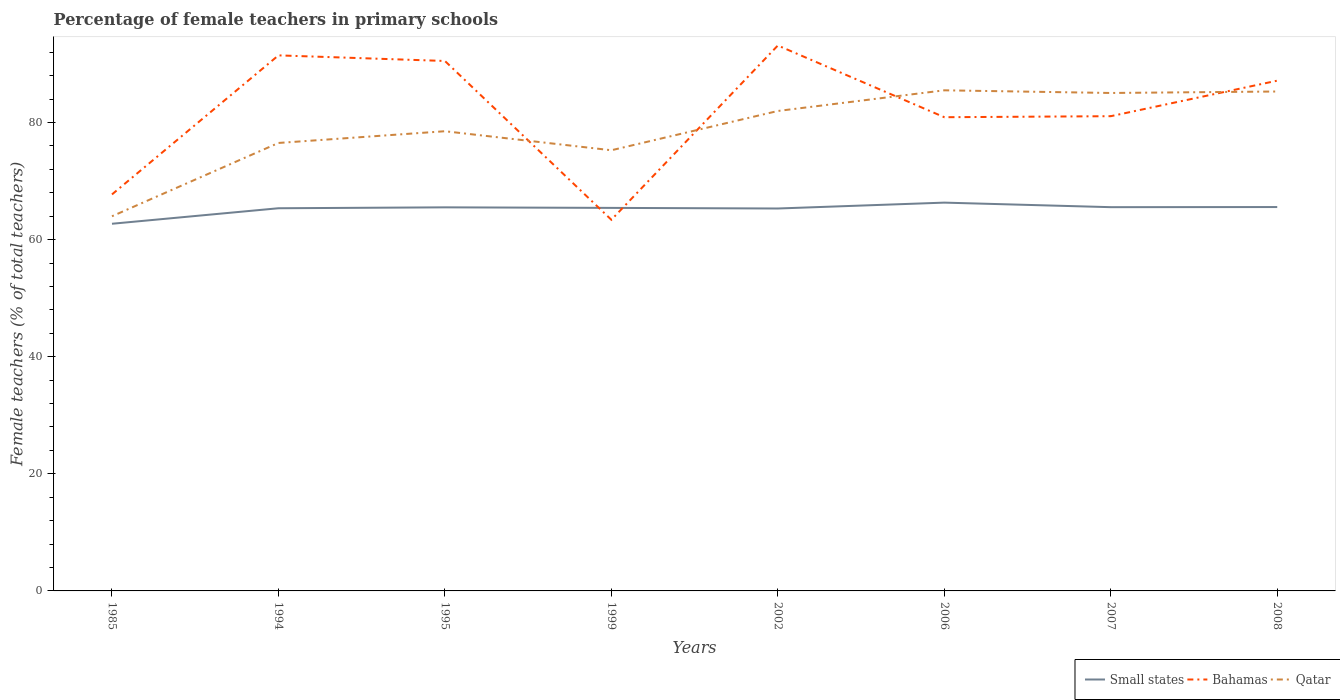Across all years, what is the maximum percentage of female teachers in Qatar?
Give a very brief answer. 63.98. What is the total percentage of female teachers in Bahamas in the graph?
Provide a short and direct response. -6.24. What is the difference between the highest and the second highest percentage of female teachers in Qatar?
Keep it short and to the point. 21.51. What is the difference between the highest and the lowest percentage of female teachers in Small states?
Your response must be concise. 7. How many years are there in the graph?
Offer a very short reply. 8. Does the graph contain any zero values?
Provide a short and direct response. No. Does the graph contain grids?
Provide a succinct answer. No. How many legend labels are there?
Provide a succinct answer. 3. How are the legend labels stacked?
Provide a short and direct response. Horizontal. What is the title of the graph?
Make the answer very short. Percentage of female teachers in primary schools. What is the label or title of the X-axis?
Your answer should be very brief. Years. What is the label or title of the Y-axis?
Provide a succinct answer. Female teachers (% of total teachers). What is the Female teachers (% of total teachers) in Small states in 1985?
Your response must be concise. 62.7. What is the Female teachers (% of total teachers) of Bahamas in 1985?
Offer a very short reply. 67.71. What is the Female teachers (% of total teachers) in Qatar in 1985?
Make the answer very short. 63.98. What is the Female teachers (% of total teachers) of Small states in 1994?
Make the answer very short. 65.35. What is the Female teachers (% of total teachers) of Bahamas in 1994?
Keep it short and to the point. 91.46. What is the Female teachers (% of total teachers) of Qatar in 1994?
Give a very brief answer. 76.5. What is the Female teachers (% of total teachers) of Small states in 1995?
Give a very brief answer. 65.51. What is the Female teachers (% of total teachers) of Bahamas in 1995?
Make the answer very short. 90.51. What is the Female teachers (% of total teachers) of Qatar in 1995?
Your response must be concise. 78.51. What is the Female teachers (% of total teachers) of Small states in 1999?
Make the answer very short. 65.41. What is the Female teachers (% of total teachers) in Bahamas in 1999?
Your answer should be very brief. 63.38. What is the Female teachers (% of total teachers) of Qatar in 1999?
Keep it short and to the point. 75.26. What is the Female teachers (% of total teachers) in Small states in 2002?
Provide a short and direct response. 65.31. What is the Female teachers (% of total teachers) in Bahamas in 2002?
Ensure brevity in your answer.  93.15. What is the Female teachers (% of total teachers) of Qatar in 2002?
Offer a terse response. 81.97. What is the Female teachers (% of total teachers) of Small states in 2006?
Your response must be concise. 66.31. What is the Female teachers (% of total teachers) in Bahamas in 2006?
Provide a short and direct response. 80.9. What is the Female teachers (% of total teachers) of Qatar in 2006?
Provide a succinct answer. 85.49. What is the Female teachers (% of total teachers) of Small states in 2007?
Your response must be concise. 65.54. What is the Female teachers (% of total teachers) in Bahamas in 2007?
Keep it short and to the point. 81.07. What is the Female teachers (% of total teachers) in Qatar in 2007?
Your response must be concise. 85.04. What is the Female teachers (% of total teachers) of Small states in 2008?
Make the answer very short. 65.56. What is the Female teachers (% of total teachers) in Bahamas in 2008?
Ensure brevity in your answer.  87.14. What is the Female teachers (% of total teachers) of Qatar in 2008?
Make the answer very short. 85.29. Across all years, what is the maximum Female teachers (% of total teachers) of Small states?
Your response must be concise. 66.31. Across all years, what is the maximum Female teachers (% of total teachers) of Bahamas?
Keep it short and to the point. 93.15. Across all years, what is the maximum Female teachers (% of total teachers) in Qatar?
Provide a succinct answer. 85.49. Across all years, what is the minimum Female teachers (% of total teachers) of Small states?
Your response must be concise. 62.7. Across all years, what is the minimum Female teachers (% of total teachers) of Bahamas?
Provide a short and direct response. 63.38. Across all years, what is the minimum Female teachers (% of total teachers) in Qatar?
Ensure brevity in your answer.  63.98. What is the total Female teachers (% of total teachers) of Small states in the graph?
Offer a terse response. 521.7. What is the total Female teachers (% of total teachers) of Bahamas in the graph?
Provide a succinct answer. 655.33. What is the total Female teachers (% of total teachers) of Qatar in the graph?
Provide a succinct answer. 632.04. What is the difference between the Female teachers (% of total teachers) of Small states in 1985 and that in 1994?
Give a very brief answer. -2.65. What is the difference between the Female teachers (% of total teachers) of Bahamas in 1985 and that in 1994?
Your answer should be compact. -23.75. What is the difference between the Female teachers (% of total teachers) in Qatar in 1985 and that in 1994?
Your response must be concise. -12.52. What is the difference between the Female teachers (% of total teachers) in Small states in 1985 and that in 1995?
Your answer should be very brief. -2.8. What is the difference between the Female teachers (% of total teachers) in Bahamas in 1985 and that in 1995?
Give a very brief answer. -22.79. What is the difference between the Female teachers (% of total teachers) of Qatar in 1985 and that in 1995?
Offer a very short reply. -14.52. What is the difference between the Female teachers (% of total teachers) in Small states in 1985 and that in 1999?
Your response must be concise. -2.71. What is the difference between the Female teachers (% of total teachers) in Bahamas in 1985 and that in 1999?
Ensure brevity in your answer.  4.33. What is the difference between the Female teachers (% of total teachers) in Qatar in 1985 and that in 1999?
Give a very brief answer. -11.27. What is the difference between the Female teachers (% of total teachers) of Small states in 1985 and that in 2002?
Your answer should be very brief. -2.61. What is the difference between the Female teachers (% of total teachers) in Bahamas in 1985 and that in 2002?
Your answer should be very brief. -25.44. What is the difference between the Female teachers (% of total teachers) of Qatar in 1985 and that in 2002?
Ensure brevity in your answer.  -17.98. What is the difference between the Female teachers (% of total teachers) of Small states in 1985 and that in 2006?
Offer a terse response. -3.61. What is the difference between the Female teachers (% of total teachers) of Bahamas in 1985 and that in 2006?
Your response must be concise. -13.19. What is the difference between the Female teachers (% of total teachers) in Qatar in 1985 and that in 2006?
Provide a short and direct response. -21.51. What is the difference between the Female teachers (% of total teachers) in Small states in 1985 and that in 2007?
Provide a short and direct response. -2.83. What is the difference between the Female teachers (% of total teachers) of Bahamas in 1985 and that in 2007?
Your response must be concise. -13.36. What is the difference between the Female teachers (% of total teachers) in Qatar in 1985 and that in 2007?
Your answer should be very brief. -21.05. What is the difference between the Female teachers (% of total teachers) in Small states in 1985 and that in 2008?
Offer a very short reply. -2.85. What is the difference between the Female teachers (% of total teachers) in Bahamas in 1985 and that in 2008?
Keep it short and to the point. -19.43. What is the difference between the Female teachers (% of total teachers) in Qatar in 1985 and that in 2008?
Make the answer very short. -21.31. What is the difference between the Female teachers (% of total teachers) of Small states in 1994 and that in 1995?
Your answer should be compact. -0.15. What is the difference between the Female teachers (% of total teachers) in Bahamas in 1994 and that in 1995?
Your answer should be very brief. 0.96. What is the difference between the Female teachers (% of total teachers) in Qatar in 1994 and that in 1995?
Keep it short and to the point. -2. What is the difference between the Female teachers (% of total teachers) in Small states in 1994 and that in 1999?
Make the answer very short. -0.06. What is the difference between the Female teachers (% of total teachers) of Bahamas in 1994 and that in 1999?
Offer a terse response. 28.08. What is the difference between the Female teachers (% of total teachers) in Qatar in 1994 and that in 1999?
Offer a very short reply. 1.24. What is the difference between the Female teachers (% of total teachers) in Small states in 1994 and that in 2002?
Your response must be concise. 0.04. What is the difference between the Female teachers (% of total teachers) in Bahamas in 1994 and that in 2002?
Your answer should be very brief. -1.69. What is the difference between the Female teachers (% of total teachers) in Qatar in 1994 and that in 2002?
Your answer should be very brief. -5.46. What is the difference between the Female teachers (% of total teachers) of Small states in 1994 and that in 2006?
Offer a very short reply. -0.96. What is the difference between the Female teachers (% of total teachers) of Bahamas in 1994 and that in 2006?
Provide a short and direct response. 10.56. What is the difference between the Female teachers (% of total teachers) in Qatar in 1994 and that in 2006?
Offer a terse response. -8.99. What is the difference between the Female teachers (% of total teachers) in Small states in 1994 and that in 2007?
Ensure brevity in your answer.  -0.18. What is the difference between the Female teachers (% of total teachers) of Bahamas in 1994 and that in 2007?
Provide a short and direct response. 10.39. What is the difference between the Female teachers (% of total teachers) of Qatar in 1994 and that in 2007?
Provide a succinct answer. -8.54. What is the difference between the Female teachers (% of total teachers) in Small states in 1994 and that in 2008?
Make the answer very short. -0.21. What is the difference between the Female teachers (% of total teachers) of Bahamas in 1994 and that in 2008?
Your answer should be very brief. 4.32. What is the difference between the Female teachers (% of total teachers) in Qatar in 1994 and that in 2008?
Your answer should be very brief. -8.79. What is the difference between the Female teachers (% of total teachers) in Small states in 1995 and that in 1999?
Offer a very short reply. 0.09. What is the difference between the Female teachers (% of total teachers) of Bahamas in 1995 and that in 1999?
Your answer should be very brief. 27.12. What is the difference between the Female teachers (% of total teachers) in Qatar in 1995 and that in 1999?
Your response must be concise. 3.25. What is the difference between the Female teachers (% of total teachers) of Small states in 1995 and that in 2002?
Offer a very short reply. 0.2. What is the difference between the Female teachers (% of total teachers) in Bahamas in 1995 and that in 2002?
Provide a succinct answer. -2.64. What is the difference between the Female teachers (% of total teachers) of Qatar in 1995 and that in 2002?
Offer a very short reply. -3.46. What is the difference between the Female teachers (% of total teachers) of Small states in 1995 and that in 2006?
Offer a terse response. -0.81. What is the difference between the Female teachers (% of total teachers) of Bahamas in 1995 and that in 2006?
Provide a succinct answer. 9.61. What is the difference between the Female teachers (% of total teachers) of Qatar in 1995 and that in 2006?
Your answer should be very brief. -6.99. What is the difference between the Female teachers (% of total teachers) in Small states in 1995 and that in 2007?
Your response must be concise. -0.03. What is the difference between the Female teachers (% of total teachers) in Bahamas in 1995 and that in 2007?
Offer a very short reply. 9.43. What is the difference between the Female teachers (% of total teachers) in Qatar in 1995 and that in 2007?
Your answer should be very brief. -6.53. What is the difference between the Female teachers (% of total teachers) of Small states in 1995 and that in 2008?
Offer a very short reply. -0.05. What is the difference between the Female teachers (% of total teachers) in Bahamas in 1995 and that in 2008?
Offer a terse response. 3.36. What is the difference between the Female teachers (% of total teachers) of Qatar in 1995 and that in 2008?
Offer a terse response. -6.78. What is the difference between the Female teachers (% of total teachers) in Small states in 1999 and that in 2002?
Offer a very short reply. 0.1. What is the difference between the Female teachers (% of total teachers) in Bahamas in 1999 and that in 2002?
Your response must be concise. -29.77. What is the difference between the Female teachers (% of total teachers) in Qatar in 1999 and that in 2002?
Your response must be concise. -6.71. What is the difference between the Female teachers (% of total teachers) in Small states in 1999 and that in 2006?
Your answer should be very brief. -0.9. What is the difference between the Female teachers (% of total teachers) of Bahamas in 1999 and that in 2006?
Ensure brevity in your answer.  -17.52. What is the difference between the Female teachers (% of total teachers) in Qatar in 1999 and that in 2006?
Your response must be concise. -10.24. What is the difference between the Female teachers (% of total teachers) of Small states in 1999 and that in 2007?
Provide a short and direct response. -0.12. What is the difference between the Female teachers (% of total teachers) of Bahamas in 1999 and that in 2007?
Make the answer very short. -17.69. What is the difference between the Female teachers (% of total teachers) of Qatar in 1999 and that in 2007?
Offer a terse response. -9.78. What is the difference between the Female teachers (% of total teachers) in Small states in 1999 and that in 2008?
Make the answer very short. -0.14. What is the difference between the Female teachers (% of total teachers) in Bahamas in 1999 and that in 2008?
Provide a short and direct response. -23.76. What is the difference between the Female teachers (% of total teachers) in Qatar in 1999 and that in 2008?
Offer a terse response. -10.03. What is the difference between the Female teachers (% of total teachers) in Small states in 2002 and that in 2006?
Keep it short and to the point. -1. What is the difference between the Female teachers (% of total teachers) in Bahamas in 2002 and that in 2006?
Ensure brevity in your answer.  12.25. What is the difference between the Female teachers (% of total teachers) of Qatar in 2002 and that in 2006?
Your answer should be compact. -3.53. What is the difference between the Female teachers (% of total teachers) of Small states in 2002 and that in 2007?
Ensure brevity in your answer.  -0.23. What is the difference between the Female teachers (% of total teachers) in Bahamas in 2002 and that in 2007?
Ensure brevity in your answer.  12.07. What is the difference between the Female teachers (% of total teachers) in Qatar in 2002 and that in 2007?
Ensure brevity in your answer.  -3.07. What is the difference between the Female teachers (% of total teachers) of Small states in 2002 and that in 2008?
Ensure brevity in your answer.  -0.25. What is the difference between the Female teachers (% of total teachers) of Bahamas in 2002 and that in 2008?
Offer a terse response. 6.01. What is the difference between the Female teachers (% of total teachers) in Qatar in 2002 and that in 2008?
Give a very brief answer. -3.33. What is the difference between the Female teachers (% of total teachers) in Small states in 2006 and that in 2007?
Offer a very short reply. 0.78. What is the difference between the Female teachers (% of total teachers) of Bahamas in 2006 and that in 2007?
Your answer should be very brief. -0.17. What is the difference between the Female teachers (% of total teachers) in Qatar in 2006 and that in 2007?
Offer a terse response. 0.46. What is the difference between the Female teachers (% of total teachers) of Small states in 2006 and that in 2008?
Keep it short and to the point. 0.75. What is the difference between the Female teachers (% of total teachers) in Bahamas in 2006 and that in 2008?
Ensure brevity in your answer.  -6.24. What is the difference between the Female teachers (% of total teachers) in Qatar in 2006 and that in 2008?
Make the answer very short. 0.2. What is the difference between the Female teachers (% of total teachers) of Small states in 2007 and that in 2008?
Offer a very short reply. -0.02. What is the difference between the Female teachers (% of total teachers) of Bahamas in 2007 and that in 2008?
Keep it short and to the point. -6.07. What is the difference between the Female teachers (% of total teachers) in Qatar in 2007 and that in 2008?
Make the answer very short. -0.25. What is the difference between the Female teachers (% of total teachers) of Small states in 1985 and the Female teachers (% of total teachers) of Bahamas in 1994?
Give a very brief answer. -28.76. What is the difference between the Female teachers (% of total teachers) in Small states in 1985 and the Female teachers (% of total teachers) in Qatar in 1994?
Your answer should be compact. -13.8. What is the difference between the Female teachers (% of total teachers) of Bahamas in 1985 and the Female teachers (% of total teachers) of Qatar in 1994?
Provide a short and direct response. -8.79. What is the difference between the Female teachers (% of total teachers) of Small states in 1985 and the Female teachers (% of total teachers) of Bahamas in 1995?
Offer a terse response. -27.8. What is the difference between the Female teachers (% of total teachers) of Small states in 1985 and the Female teachers (% of total teachers) of Qatar in 1995?
Keep it short and to the point. -15.8. What is the difference between the Female teachers (% of total teachers) of Bahamas in 1985 and the Female teachers (% of total teachers) of Qatar in 1995?
Offer a terse response. -10.79. What is the difference between the Female teachers (% of total teachers) in Small states in 1985 and the Female teachers (% of total teachers) in Bahamas in 1999?
Your answer should be very brief. -0.68. What is the difference between the Female teachers (% of total teachers) in Small states in 1985 and the Female teachers (% of total teachers) in Qatar in 1999?
Keep it short and to the point. -12.55. What is the difference between the Female teachers (% of total teachers) of Bahamas in 1985 and the Female teachers (% of total teachers) of Qatar in 1999?
Offer a terse response. -7.55. What is the difference between the Female teachers (% of total teachers) of Small states in 1985 and the Female teachers (% of total teachers) of Bahamas in 2002?
Give a very brief answer. -30.45. What is the difference between the Female teachers (% of total teachers) of Small states in 1985 and the Female teachers (% of total teachers) of Qatar in 2002?
Provide a succinct answer. -19.26. What is the difference between the Female teachers (% of total teachers) of Bahamas in 1985 and the Female teachers (% of total teachers) of Qatar in 2002?
Offer a terse response. -14.25. What is the difference between the Female teachers (% of total teachers) of Small states in 1985 and the Female teachers (% of total teachers) of Bahamas in 2006?
Keep it short and to the point. -18.2. What is the difference between the Female teachers (% of total teachers) of Small states in 1985 and the Female teachers (% of total teachers) of Qatar in 2006?
Your answer should be very brief. -22.79. What is the difference between the Female teachers (% of total teachers) in Bahamas in 1985 and the Female teachers (% of total teachers) in Qatar in 2006?
Offer a terse response. -17.78. What is the difference between the Female teachers (% of total teachers) in Small states in 1985 and the Female teachers (% of total teachers) in Bahamas in 2007?
Your answer should be very brief. -18.37. What is the difference between the Female teachers (% of total teachers) of Small states in 1985 and the Female teachers (% of total teachers) of Qatar in 2007?
Keep it short and to the point. -22.33. What is the difference between the Female teachers (% of total teachers) of Bahamas in 1985 and the Female teachers (% of total teachers) of Qatar in 2007?
Give a very brief answer. -17.33. What is the difference between the Female teachers (% of total teachers) of Small states in 1985 and the Female teachers (% of total teachers) of Bahamas in 2008?
Keep it short and to the point. -24.44. What is the difference between the Female teachers (% of total teachers) of Small states in 1985 and the Female teachers (% of total teachers) of Qatar in 2008?
Offer a terse response. -22.59. What is the difference between the Female teachers (% of total teachers) in Bahamas in 1985 and the Female teachers (% of total teachers) in Qatar in 2008?
Make the answer very short. -17.58. What is the difference between the Female teachers (% of total teachers) of Small states in 1994 and the Female teachers (% of total teachers) of Bahamas in 1995?
Ensure brevity in your answer.  -25.15. What is the difference between the Female teachers (% of total teachers) of Small states in 1994 and the Female teachers (% of total teachers) of Qatar in 1995?
Ensure brevity in your answer.  -13.15. What is the difference between the Female teachers (% of total teachers) of Bahamas in 1994 and the Female teachers (% of total teachers) of Qatar in 1995?
Provide a short and direct response. 12.95. What is the difference between the Female teachers (% of total teachers) in Small states in 1994 and the Female teachers (% of total teachers) in Bahamas in 1999?
Make the answer very short. 1.97. What is the difference between the Female teachers (% of total teachers) in Small states in 1994 and the Female teachers (% of total teachers) in Qatar in 1999?
Provide a short and direct response. -9.91. What is the difference between the Female teachers (% of total teachers) in Bahamas in 1994 and the Female teachers (% of total teachers) in Qatar in 1999?
Keep it short and to the point. 16.2. What is the difference between the Female teachers (% of total teachers) of Small states in 1994 and the Female teachers (% of total teachers) of Bahamas in 2002?
Provide a short and direct response. -27.8. What is the difference between the Female teachers (% of total teachers) of Small states in 1994 and the Female teachers (% of total teachers) of Qatar in 2002?
Provide a short and direct response. -16.61. What is the difference between the Female teachers (% of total teachers) in Bahamas in 1994 and the Female teachers (% of total teachers) in Qatar in 2002?
Offer a terse response. 9.5. What is the difference between the Female teachers (% of total teachers) of Small states in 1994 and the Female teachers (% of total teachers) of Bahamas in 2006?
Your answer should be very brief. -15.55. What is the difference between the Female teachers (% of total teachers) in Small states in 1994 and the Female teachers (% of total teachers) in Qatar in 2006?
Provide a succinct answer. -20.14. What is the difference between the Female teachers (% of total teachers) of Bahamas in 1994 and the Female teachers (% of total teachers) of Qatar in 2006?
Provide a short and direct response. 5.97. What is the difference between the Female teachers (% of total teachers) in Small states in 1994 and the Female teachers (% of total teachers) in Bahamas in 2007?
Provide a short and direct response. -15.72. What is the difference between the Female teachers (% of total teachers) of Small states in 1994 and the Female teachers (% of total teachers) of Qatar in 2007?
Ensure brevity in your answer.  -19.69. What is the difference between the Female teachers (% of total teachers) in Bahamas in 1994 and the Female teachers (% of total teachers) in Qatar in 2007?
Your answer should be very brief. 6.42. What is the difference between the Female teachers (% of total teachers) in Small states in 1994 and the Female teachers (% of total teachers) in Bahamas in 2008?
Ensure brevity in your answer.  -21.79. What is the difference between the Female teachers (% of total teachers) in Small states in 1994 and the Female teachers (% of total teachers) in Qatar in 2008?
Offer a very short reply. -19.94. What is the difference between the Female teachers (% of total teachers) in Bahamas in 1994 and the Female teachers (% of total teachers) in Qatar in 2008?
Offer a very short reply. 6.17. What is the difference between the Female teachers (% of total teachers) in Small states in 1995 and the Female teachers (% of total teachers) in Bahamas in 1999?
Provide a short and direct response. 2.12. What is the difference between the Female teachers (% of total teachers) in Small states in 1995 and the Female teachers (% of total teachers) in Qatar in 1999?
Your answer should be compact. -9.75. What is the difference between the Female teachers (% of total teachers) of Bahamas in 1995 and the Female teachers (% of total teachers) of Qatar in 1999?
Ensure brevity in your answer.  15.25. What is the difference between the Female teachers (% of total teachers) in Small states in 1995 and the Female teachers (% of total teachers) in Bahamas in 2002?
Ensure brevity in your answer.  -27.64. What is the difference between the Female teachers (% of total teachers) in Small states in 1995 and the Female teachers (% of total teachers) in Qatar in 2002?
Provide a succinct answer. -16.46. What is the difference between the Female teachers (% of total teachers) of Bahamas in 1995 and the Female teachers (% of total teachers) of Qatar in 2002?
Make the answer very short. 8.54. What is the difference between the Female teachers (% of total teachers) in Small states in 1995 and the Female teachers (% of total teachers) in Bahamas in 2006?
Your answer should be compact. -15.39. What is the difference between the Female teachers (% of total teachers) of Small states in 1995 and the Female teachers (% of total teachers) of Qatar in 2006?
Offer a very short reply. -19.99. What is the difference between the Female teachers (% of total teachers) in Bahamas in 1995 and the Female teachers (% of total teachers) in Qatar in 2006?
Your response must be concise. 5.01. What is the difference between the Female teachers (% of total teachers) in Small states in 1995 and the Female teachers (% of total teachers) in Bahamas in 2007?
Give a very brief answer. -15.57. What is the difference between the Female teachers (% of total teachers) in Small states in 1995 and the Female teachers (% of total teachers) in Qatar in 2007?
Your response must be concise. -19.53. What is the difference between the Female teachers (% of total teachers) in Bahamas in 1995 and the Female teachers (% of total teachers) in Qatar in 2007?
Offer a very short reply. 5.47. What is the difference between the Female teachers (% of total teachers) of Small states in 1995 and the Female teachers (% of total teachers) of Bahamas in 2008?
Your response must be concise. -21.63. What is the difference between the Female teachers (% of total teachers) in Small states in 1995 and the Female teachers (% of total teachers) in Qatar in 2008?
Your response must be concise. -19.78. What is the difference between the Female teachers (% of total teachers) in Bahamas in 1995 and the Female teachers (% of total teachers) in Qatar in 2008?
Make the answer very short. 5.21. What is the difference between the Female teachers (% of total teachers) in Small states in 1999 and the Female teachers (% of total teachers) in Bahamas in 2002?
Give a very brief answer. -27.73. What is the difference between the Female teachers (% of total teachers) of Small states in 1999 and the Female teachers (% of total teachers) of Qatar in 2002?
Make the answer very short. -16.55. What is the difference between the Female teachers (% of total teachers) in Bahamas in 1999 and the Female teachers (% of total teachers) in Qatar in 2002?
Provide a succinct answer. -18.58. What is the difference between the Female teachers (% of total teachers) in Small states in 1999 and the Female teachers (% of total teachers) in Bahamas in 2006?
Offer a terse response. -15.48. What is the difference between the Female teachers (% of total teachers) in Small states in 1999 and the Female teachers (% of total teachers) in Qatar in 2006?
Make the answer very short. -20.08. What is the difference between the Female teachers (% of total teachers) in Bahamas in 1999 and the Female teachers (% of total teachers) in Qatar in 2006?
Your answer should be compact. -22.11. What is the difference between the Female teachers (% of total teachers) in Small states in 1999 and the Female teachers (% of total teachers) in Bahamas in 2007?
Ensure brevity in your answer.  -15.66. What is the difference between the Female teachers (% of total teachers) in Small states in 1999 and the Female teachers (% of total teachers) in Qatar in 2007?
Offer a very short reply. -19.62. What is the difference between the Female teachers (% of total teachers) in Bahamas in 1999 and the Female teachers (% of total teachers) in Qatar in 2007?
Ensure brevity in your answer.  -21.66. What is the difference between the Female teachers (% of total teachers) of Small states in 1999 and the Female teachers (% of total teachers) of Bahamas in 2008?
Your answer should be very brief. -21.73. What is the difference between the Female teachers (% of total teachers) in Small states in 1999 and the Female teachers (% of total teachers) in Qatar in 2008?
Offer a very short reply. -19.88. What is the difference between the Female teachers (% of total teachers) in Bahamas in 1999 and the Female teachers (% of total teachers) in Qatar in 2008?
Keep it short and to the point. -21.91. What is the difference between the Female teachers (% of total teachers) of Small states in 2002 and the Female teachers (% of total teachers) of Bahamas in 2006?
Keep it short and to the point. -15.59. What is the difference between the Female teachers (% of total teachers) in Small states in 2002 and the Female teachers (% of total teachers) in Qatar in 2006?
Your response must be concise. -20.18. What is the difference between the Female teachers (% of total teachers) of Bahamas in 2002 and the Female teachers (% of total teachers) of Qatar in 2006?
Offer a terse response. 7.65. What is the difference between the Female teachers (% of total teachers) in Small states in 2002 and the Female teachers (% of total teachers) in Bahamas in 2007?
Your answer should be very brief. -15.76. What is the difference between the Female teachers (% of total teachers) of Small states in 2002 and the Female teachers (% of total teachers) of Qatar in 2007?
Your answer should be very brief. -19.73. What is the difference between the Female teachers (% of total teachers) of Bahamas in 2002 and the Female teachers (% of total teachers) of Qatar in 2007?
Make the answer very short. 8.11. What is the difference between the Female teachers (% of total teachers) in Small states in 2002 and the Female teachers (% of total teachers) in Bahamas in 2008?
Provide a succinct answer. -21.83. What is the difference between the Female teachers (% of total teachers) in Small states in 2002 and the Female teachers (% of total teachers) in Qatar in 2008?
Offer a very short reply. -19.98. What is the difference between the Female teachers (% of total teachers) in Bahamas in 2002 and the Female teachers (% of total teachers) in Qatar in 2008?
Your answer should be compact. 7.86. What is the difference between the Female teachers (% of total teachers) of Small states in 2006 and the Female teachers (% of total teachers) of Bahamas in 2007?
Offer a terse response. -14.76. What is the difference between the Female teachers (% of total teachers) in Small states in 2006 and the Female teachers (% of total teachers) in Qatar in 2007?
Provide a short and direct response. -18.73. What is the difference between the Female teachers (% of total teachers) of Bahamas in 2006 and the Female teachers (% of total teachers) of Qatar in 2007?
Keep it short and to the point. -4.14. What is the difference between the Female teachers (% of total teachers) in Small states in 2006 and the Female teachers (% of total teachers) in Bahamas in 2008?
Ensure brevity in your answer.  -20.83. What is the difference between the Female teachers (% of total teachers) in Small states in 2006 and the Female teachers (% of total teachers) in Qatar in 2008?
Ensure brevity in your answer.  -18.98. What is the difference between the Female teachers (% of total teachers) in Bahamas in 2006 and the Female teachers (% of total teachers) in Qatar in 2008?
Offer a terse response. -4.39. What is the difference between the Female teachers (% of total teachers) of Small states in 2007 and the Female teachers (% of total teachers) of Bahamas in 2008?
Your answer should be compact. -21.61. What is the difference between the Female teachers (% of total teachers) of Small states in 2007 and the Female teachers (% of total teachers) of Qatar in 2008?
Provide a succinct answer. -19.76. What is the difference between the Female teachers (% of total teachers) in Bahamas in 2007 and the Female teachers (% of total teachers) in Qatar in 2008?
Your answer should be compact. -4.22. What is the average Female teachers (% of total teachers) in Small states per year?
Make the answer very short. 65.21. What is the average Female teachers (% of total teachers) of Bahamas per year?
Provide a succinct answer. 81.92. What is the average Female teachers (% of total teachers) in Qatar per year?
Provide a short and direct response. 79.01. In the year 1985, what is the difference between the Female teachers (% of total teachers) of Small states and Female teachers (% of total teachers) of Bahamas?
Your answer should be compact. -5.01. In the year 1985, what is the difference between the Female teachers (% of total teachers) in Small states and Female teachers (% of total teachers) in Qatar?
Make the answer very short. -1.28. In the year 1985, what is the difference between the Female teachers (% of total teachers) of Bahamas and Female teachers (% of total teachers) of Qatar?
Give a very brief answer. 3.73. In the year 1994, what is the difference between the Female teachers (% of total teachers) of Small states and Female teachers (% of total teachers) of Bahamas?
Your answer should be very brief. -26.11. In the year 1994, what is the difference between the Female teachers (% of total teachers) of Small states and Female teachers (% of total teachers) of Qatar?
Make the answer very short. -11.15. In the year 1994, what is the difference between the Female teachers (% of total teachers) of Bahamas and Female teachers (% of total teachers) of Qatar?
Give a very brief answer. 14.96. In the year 1995, what is the difference between the Female teachers (% of total teachers) of Small states and Female teachers (% of total teachers) of Bahamas?
Offer a very short reply. -25. In the year 1995, what is the difference between the Female teachers (% of total teachers) in Small states and Female teachers (% of total teachers) in Qatar?
Ensure brevity in your answer.  -13. In the year 1995, what is the difference between the Female teachers (% of total teachers) in Bahamas and Female teachers (% of total teachers) in Qatar?
Your answer should be compact. 12. In the year 1999, what is the difference between the Female teachers (% of total teachers) in Small states and Female teachers (% of total teachers) in Bahamas?
Offer a terse response. 2.03. In the year 1999, what is the difference between the Female teachers (% of total teachers) of Small states and Female teachers (% of total teachers) of Qatar?
Your answer should be compact. -9.84. In the year 1999, what is the difference between the Female teachers (% of total teachers) of Bahamas and Female teachers (% of total teachers) of Qatar?
Your answer should be very brief. -11.88. In the year 2002, what is the difference between the Female teachers (% of total teachers) in Small states and Female teachers (% of total teachers) in Bahamas?
Provide a short and direct response. -27.84. In the year 2002, what is the difference between the Female teachers (% of total teachers) of Small states and Female teachers (% of total teachers) of Qatar?
Provide a succinct answer. -16.65. In the year 2002, what is the difference between the Female teachers (% of total teachers) in Bahamas and Female teachers (% of total teachers) in Qatar?
Offer a terse response. 11.18. In the year 2006, what is the difference between the Female teachers (% of total teachers) of Small states and Female teachers (% of total teachers) of Bahamas?
Your answer should be compact. -14.59. In the year 2006, what is the difference between the Female teachers (% of total teachers) of Small states and Female teachers (% of total teachers) of Qatar?
Your response must be concise. -19.18. In the year 2006, what is the difference between the Female teachers (% of total teachers) in Bahamas and Female teachers (% of total teachers) in Qatar?
Your response must be concise. -4.6. In the year 2007, what is the difference between the Female teachers (% of total teachers) of Small states and Female teachers (% of total teachers) of Bahamas?
Ensure brevity in your answer.  -15.54. In the year 2007, what is the difference between the Female teachers (% of total teachers) in Small states and Female teachers (% of total teachers) in Qatar?
Offer a terse response. -19.5. In the year 2007, what is the difference between the Female teachers (% of total teachers) in Bahamas and Female teachers (% of total teachers) in Qatar?
Make the answer very short. -3.96. In the year 2008, what is the difference between the Female teachers (% of total teachers) of Small states and Female teachers (% of total teachers) of Bahamas?
Ensure brevity in your answer.  -21.58. In the year 2008, what is the difference between the Female teachers (% of total teachers) of Small states and Female teachers (% of total teachers) of Qatar?
Provide a succinct answer. -19.73. In the year 2008, what is the difference between the Female teachers (% of total teachers) in Bahamas and Female teachers (% of total teachers) in Qatar?
Provide a short and direct response. 1.85. What is the ratio of the Female teachers (% of total teachers) of Small states in 1985 to that in 1994?
Your response must be concise. 0.96. What is the ratio of the Female teachers (% of total teachers) of Bahamas in 1985 to that in 1994?
Ensure brevity in your answer.  0.74. What is the ratio of the Female teachers (% of total teachers) in Qatar in 1985 to that in 1994?
Provide a succinct answer. 0.84. What is the ratio of the Female teachers (% of total teachers) of Small states in 1985 to that in 1995?
Ensure brevity in your answer.  0.96. What is the ratio of the Female teachers (% of total teachers) in Bahamas in 1985 to that in 1995?
Offer a very short reply. 0.75. What is the ratio of the Female teachers (% of total teachers) of Qatar in 1985 to that in 1995?
Keep it short and to the point. 0.81. What is the ratio of the Female teachers (% of total teachers) of Small states in 1985 to that in 1999?
Your answer should be very brief. 0.96. What is the ratio of the Female teachers (% of total teachers) of Bahamas in 1985 to that in 1999?
Make the answer very short. 1.07. What is the ratio of the Female teachers (% of total teachers) in Qatar in 1985 to that in 1999?
Keep it short and to the point. 0.85. What is the ratio of the Female teachers (% of total teachers) in Small states in 1985 to that in 2002?
Your answer should be very brief. 0.96. What is the ratio of the Female teachers (% of total teachers) in Bahamas in 1985 to that in 2002?
Your answer should be very brief. 0.73. What is the ratio of the Female teachers (% of total teachers) of Qatar in 1985 to that in 2002?
Your answer should be compact. 0.78. What is the ratio of the Female teachers (% of total teachers) in Small states in 1985 to that in 2006?
Give a very brief answer. 0.95. What is the ratio of the Female teachers (% of total teachers) of Bahamas in 1985 to that in 2006?
Provide a succinct answer. 0.84. What is the ratio of the Female teachers (% of total teachers) of Qatar in 1985 to that in 2006?
Your answer should be very brief. 0.75. What is the ratio of the Female teachers (% of total teachers) in Small states in 1985 to that in 2007?
Your answer should be compact. 0.96. What is the ratio of the Female teachers (% of total teachers) in Bahamas in 1985 to that in 2007?
Your answer should be compact. 0.84. What is the ratio of the Female teachers (% of total teachers) of Qatar in 1985 to that in 2007?
Ensure brevity in your answer.  0.75. What is the ratio of the Female teachers (% of total teachers) of Small states in 1985 to that in 2008?
Your answer should be very brief. 0.96. What is the ratio of the Female teachers (% of total teachers) of Bahamas in 1985 to that in 2008?
Your answer should be very brief. 0.78. What is the ratio of the Female teachers (% of total teachers) of Qatar in 1985 to that in 2008?
Give a very brief answer. 0.75. What is the ratio of the Female teachers (% of total teachers) in Small states in 1994 to that in 1995?
Ensure brevity in your answer.  1. What is the ratio of the Female teachers (% of total teachers) of Bahamas in 1994 to that in 1995?
Provide a succinct answer. 1.01. What is the ratio of the Female teachers (% of total teachers) in Qatar in 1994 to that in 1995?
Offer a terse response. 0.97. What is the ratio of the Female teachers (% of total teachers) of Bahamas in 1994 to that in 1999?
Your response must be concise. 1.44. What is the ratio of the Female teachers (% of total teachers) in Qatar in 1994 to that in 1999?
Provide a succinct answer. 1.02. What is the ratio of the Female teachers (% of total teachers) of Small states in 1994 to that in 2002?
Offer a very short reply. 1. What is the ratio of the Female teachers (% of total teachers) of Bahamas in 1994 to that in 2002?
Provide a succinct answer. 0.98. What is the ratio of the Female teachers (% of total teachers) of Qatar in 1994 to that in 2002?
Make the answer very short. 0.93. What is the ratio of the Female teachers (% of total teachers) in Small states in 1994 to that in 2006?
Ensure brevity in your answer.  0.99. What is the ratio of the Female teachers (% of total teachers) of Bahamas in 1994 to that in 2006?
Your answer should be compact. 1.13. What is the ratio of the Female teachers (% of total teachers) in Qatar in 1994 to that in 2006?
Your response must be concise. 0.89. What is the ratio of the Female teachers (% of total teachers) of Small states in 1994 to that in 2007?
Provide a short and direct response. 1. What is the ratio of the Female teachers (% of total teachers) of Bahamas in 1994 to that in 2007?
Provide a short and direct response. 1.13. What is the ratio of the Female teachers (% of total teachers) of Qatar in 1994 to that in 2007?
Provide a succinct answer. 0.9. What is the ratio of the Female teachers (% of total teachers) in Bahamas in 1994 to that in 2008?
Make the answer very short. 1.05. What is the ratio of the Female teachers (% of total teachers) in Qatar in 1994 to that in 2008?
Your response must be concise. 0.9. What is the ratio of the Female teachers (% of total teachers) of Small states in 1995 to that in 1999?
Make the answer very short. 1. What is the ratio of the Female teachers (% of total teachers) of Bahamas in 1995 to that in 1999?
Make the answer very short. 1.43. What is the ratio of the Female teachers (% of total teachers) in Qatar in 1995 to that in 1999?
Your answer should be compact. 1.04. What is the ratio of the Female teachers (% of total teachers) of Small states in 1995 to that in 2002?
Keep it short and to the point. 1. What is the ratio of the Female teachers (% of total teachers) of Bahamas in 1995 to that in 2002?
Ensure brevity in your answer.  0.97. What is the ratio of the Female teachers (% of total teachers) of Qatar in 1995 to that in 2002?
Provide a short and direct response. 0.96. What is the ratio of the Female teachers (% of total teachers) of Small states in 1995 to that in 2006?
Ensure brevity in your answer.  0.99. What is the ratio of the Female teachers (% of total teachers) in Bahamas in 1995 to that in 2006?
Your response must be concise. 1.12. What is the ratio of the Female teachers (% of total teachers) of Qatar in 1995 to that in 2006?
Your answer should be compact. 0.92. What is the ratio of the Female teachers (% of total teachers) of Bahamas in 1995 to that in 2007?
Provide a short and direct response. 1.12. What is the ratio of the Female teachers (% of total teachers) in Qatar in 1995 to that in 2007?
Your answer should be very brief. 0.92. What is the ratio of the Female teachers (% of total teachers) of Small states in 1995 to that in 2008?
Offer a terse response. 1. What is the ratio of the Female teachers (% of total teachers) of Bahamas in 1995 to that in 2008?
Make the answer very short. 1.04. What is the ratio of the Female teachers (% of total teachers) of Qatar in 1995 to that in 2008?
Provide a short and direct response. 0.92. What is the ratio of the Female teachers (% of total teachers) of Small states in 1999 to that in 2002?
Your response must be concise. 1. What is the ratio of the Female teachers (% of total teachers) in Bahamas in 1999 to that in 2002?
Your answer should be very brief. 0.68. What is the ratio of the Female teachers (% of total teachers) of Qatar in 1999 to that in 2002?
Ensure brevity in your answer.  0.92. What is the ratio of the Female teachers (% of total teachers) of Small states in 1999 to that in 2006?
Your response must be concise. 0.99. What is the ratio of the Female teachers (% of total teachers) in Bahamas in 1999 to that in 2006?
Provide a succinct answer. 0.78. What is the ratio of the Female teachers (% of total teachers) in Qatar in 1999 to that in 2006?
Provide a short and direct response. 0.88. What is the ratio of the Female teachers (% of total teachers) in Bahamas in 1999 to that in 2007?
Give a very brief answer. 0.78. What is the ratio of the Female teachers (% of total teachers) in Qatar in 1999 to that in 2007?
Provide a short and direct response. 0.89. What is the ratio of the Female teachers (% of total teachers) in Bahamas in 1999 to that in 2008?
Give a very brief answer. 0.73. What is the ratio of the Female teachers (% of total teachers) in Qatar in 1999 to that in 2008?
Keep it short and to the point. 0.88. What is the ratio of the Female teachers (% of total teachers) of Small states in 2002 to that in 2006?
Provide a short and direct response. 0.98. What is the ratio of the Female teachers (% of total teachers) of Bahamas in 2002 to that in 2006?
Offer a very short reply. 1.15. What is the ratio of the Female teachers (% of total teachers) in Qatar in 2002 to that in 2006?
Offer a very short reply. 0.96. What is the ratio of the Female teachers (% of total teachers) of Small states in 2002 to that in 2007?
Provide a succinct answer. 1. What is the ratio of the Female teachers (% of total teachers) in Bahamas in 2002 to that in 2007?
Ensure brevity in your answer.  1.15. What is the ratio of the Female teachers (% of total teachers) of Qatar in 2002 to that in 2007?
Your answer should be very brief. 0.96. What is the ratio of the Female teachers (% of total teachers) in Small states in 2002 to that in 2008?
Make the answer very short. 1. What is the ratio of the Female teachers (% of total teachers) in Bahamas in 2002 to that in 2008?
Your answer should be compact. 1.07. What is the ratio of the Female teachers (% of total teachers) of Qatar in 2002 to that in 2008?
Your response must be concise. 0.96. What is the ratio of the Female teachers (% of total teachers) in Small states in 2006 to that in 2007?
Keep it short and to the point. 1.01. What is the ratio of the Female teachers (% of total teachers) of Qatar in 2006 to that in 2007?
Your response must be concise. 1.01. What is the ratio of the Female teachers (% of total teachers) of Small states in 2006 to that in 2008?
Your response must be concise. 1.01. What is the ratio of the Female teachers (% of total teachers) of Bahamas in 2006 to that in 2008?
Provide a short and direct response. 0.93. What is the ratio of the Female teachers (% of total teachers) of Qatar in 2006 to that in 2008?
Give a very brief answer. 1. What is the ratio of the Female teachers (% of total teachers) in Bahamas in 2007 to that in 2008?
Offer a very short reply. 0.93. What is the ratio of the Female teachers (% of total teachers) in Qatar in 2007 to that in 2008?
Make the answer very short. 1. What is the difference between the highest and the second highest Female teachers (% of total teachers) in Small states?
Make the answer very short. 0.75. What is the difference between the highest and the second highest Female teachers (% of total teachers) of Bahamas?
Your answer should be compact. 1.69. What is the difference between the highest and the second highest Female teachers (% of total teachers) of Qatar?
Offer a very short reply. 0.2. What is the difference between the highest and the lowest Female teachers (% of total teachers) of Small states?
Give a very brief answer. 3.61. What is the difference between the highest and the lowest Female teachers (% of total teachers) of Bahamas?
Provide a short and direct response. 29.77. What is the difference between the highest and the lowest Female teachers (% of total teachers) of Qatar?
Give a very brief answer. 21.51. 